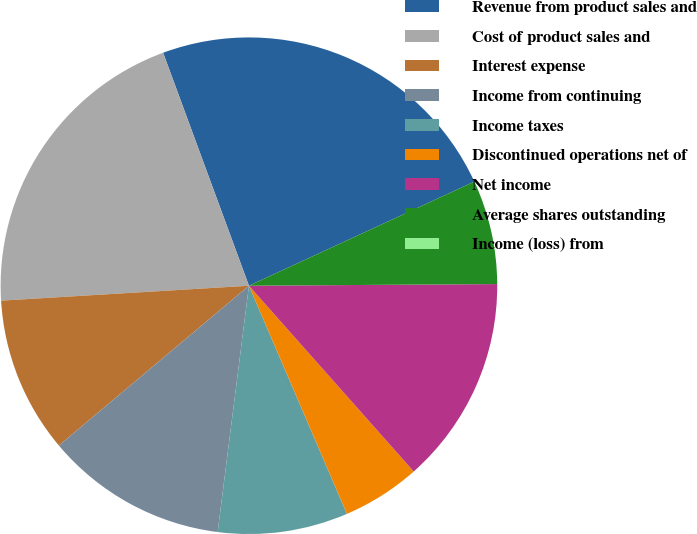<chart> <loc_0><loc_0><loc_500><loc_500><pie_chart><fcel>Revenue from product sales and<fcel>Cost of product sales and<fcel>Interest expense<fcel>Income from continuing<fcel>Income taxes<fcel>Discontinued operations net of<fcel>Net income<fcel>Average shares outstanding<fcel>Income (loss) from<nl><fcel>23.73%<fcel>20.34%<fcel>10.17%<fcel>11.86%<fcel>8.47%<fcel>5.09%<fcel>13.56%<fcel>6.78%<fcel>0.0%<nl></chart> 